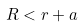<formula> <loc_0><loc_0><loc_500><loc_500>R < r + a</formula> 